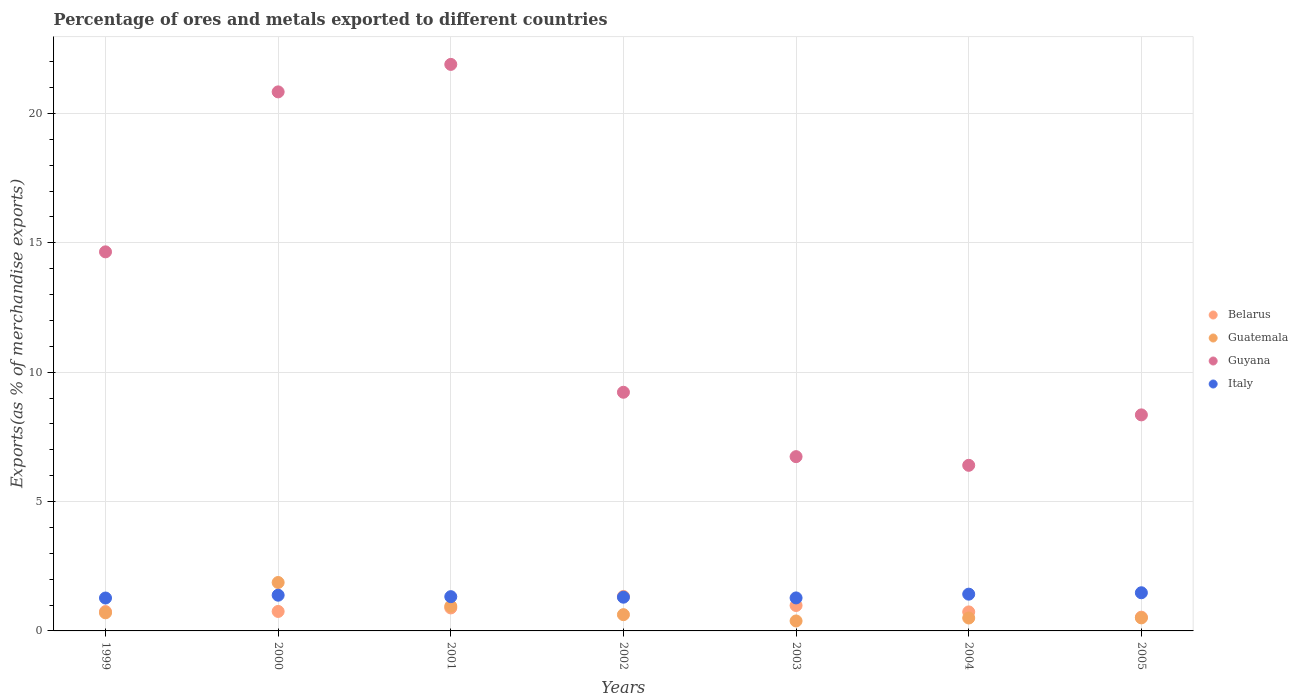How many different coloured dotlines are there?
Provide a short and direct response. 4. Is the number of dotlines equal to the number of legend labels?
Offer a terse response. Yes. What is the percentage of exports to different countries in Guatemala in 2004?
Provide a short and direct response. 0.5. Across all years, what is the maximum percentage of exports to different countries in Italy?
Your answer should be very brief. 1.48. Across all years, what is the minimum percentage of exports to different countries in Guyana?
Offer a very short reply. 6.4. In which year was the percentage of exports to different countries in Guyana maximum?
Your response must be concise. 2001. What is the total percentage of exports to different countries in Guatemala in the graph?
Your response must be concise. 5.54. What is the difference between the percentage of exports to different countries in Italy in 2001 and that in 2002?
Offer a very short reply. 0.02. What is the difference between the percentage of exports to different countries in Guyana in 2004 and the percentage of exports to different countries in Italy in 2003?
Your answer should be compact. 5.13. What is the average percentage of exports to different countries in Guatemala per year?
Make the answer very short. 0.79. In the year 2001, what is the difference between the percentage of exports to different countries in Guatemala and percentage of exports to different countries in Belarus?
Your answer should be very brief. 0.07. What is the ratio of the percentage of exports to different countries in Italy in 1999 to that in 2005?
Keep it short and to the point. 0.86. Is the difference between the percentage of exports to different countries in Guatemala in 2002 and 2005 greater than the difference between the percentage of exports to different countries in Belarus in 2002 and 2005?
Offer a very short reply. No. What is the difference between the highest and the second highest percentage of exports to different countries in Italy?
Make the answer very short. 0.05. What is the difference between the highest and the lowest percentage of exports to different countries in Guyana?
Offer a terse response. 15.5. Is the sum of the percentage of exports to different countries in Italy in 2001 and 2004 greater than the maximum percentage of exports to different countries in Guatemala across all years?
Give a very brief answer. Yes. Is it the case that in every year, the sum of the percentage of exports to different countries in Italy and percentage of exports to different countries in Guatemala  is greater than the percentage of exports to different countries in Guyana?
Your answer should be very brief. No. Does the percentage of exports to different countries in Guatemala monotonically increase over the years?
Ensure brevity in your answer.  No. Is the percentage of exports to different countries in Belarus strictly greater than the percentage of exports to different countries in Guatemala over the years?
Your response must be concise. No. How many dotlines are there?
Keep it short and to the point. 4. Are the values on the major ticks of Y-axis written in scientific E-notation?
Provide a short and direct response. No. Does the graph contain any zero values?
Make the answer very short. No. Does the graph contain grids?
Your answer should be compact. Yes. Where does the legend appear in the graph?
Make the answer very short. Center right. How are the legend labels stacked?
Give a very brief answer. Vertical. What is the title of the graph?
Your answer should be compact. Percentage of ores and metals exported to different countries. Does "Haiti" appear as one of the legend labels in the graph?
Give a very brief answer. No. What is the label or title of the Y-axis?
Provide a short and direct response. Exports(as % of merchandise exports). What is the Exports(as % of merchandise exports) in Belarus in 1999?
Offer a very short reply. 0.75. What is the Exports(as % of merchandise exports) of Guatemala in 1999?
Offer a terse response. 0.7. What is the Exports(as % of merchandise exports) in Guyana in 1999?
Give a very brief answer. 14.65. What is the Exports(as % of merchandise exports) of Italy in 1999?
Your answer should be very brief. 1.27. What is the Exports(as % of merchandise exports) of Belarus in 2000?
Make the answer very short. 0.75. What is the Exports(as % of merchandise exports) of Guatemala in 2000?
Your answer should be compact. 1.87. What is the Exports(as % of merchandise exports) of Guyana in 2000?
Provide a succinct answer. 20.83. What is the Exports(as % of merchandise exports) in Italy in 2000?
Offer a terse response. 1.38. What is the Exports(as % of merchandise exports) in Belarus in 2001?
Provide a short and direct response. 0.89. What is the Exports(as % of merchandise exports) in Guatemala in 2001?
Your answer should be compact. 0.96. What is the Exports(as % of merchandise exports) of Guyana in 2001?
Your answer should be very brief. 21.9. What is the Exports(as % of merchandise exports) in Italy in 2001?
Provide a short and direct response. 1.32. What is the Exports(as % of merchandise exports) in Belarus in 2002?
Ensure brevity in your answer.  1.33. What is the Exports(as % of merchandise exports) of Guatemala in 2002?
Give a very brief answer. 0.63. What is the Exports(as % of merchandise exports) of Guyana in 2002?
Your response must be concise. 9.22. What is the Exports(as % of merchandise exports) of Italy in 2002?
Provide a succinct answer. 1.3. What is the Exports(as % of merchandise exports) in Belarus in 2003?
Provide a short and direct response. 0.98. What is the Exports(as % of merchandise exports) in Guatemala in 2003?
Ensure brevity in your answer.  0.39. What is the Exports(as % of merchandise exports) of Guyana in 2003?
Your response must be concise. 6.74. What is the Exports(as % of merchandise exports) of Italy in 2003?
Make the answer very short. 1.28. What is the Exports(as % of merchandise exports) of Belarus in 2004?
Make the answer very short. 0.73. What is the Exports(as % of merchandise exports) in Guatemala in 2004?
Provide a succinct answer. 0.5. What is the Exports(as % of merchandise exports) in Guyana in 2004?
Provide a short and direct response. 6.4. What is the Exports(as % of merchandise exports) in Italy in 2004?
Offer a terse response. 1.42. What is the Exports(as % of merchandise exports) of Belarus in 2005?
Provide a short and direct response. 0.53. What is the Exports(as % of merchandise exports) in Guatemala in 2005?
Offer a terse response. 0.5. What is the Exports(as % of merchandise exports) in Guyana in 2005?
Offer a terse response. 8.35. What is the Exports(as % of merchandise exports) in Italy in 2005?
Offer a very short reply. 1.48. Across all years, what is the maximum Exports(as % of merchandise exports) of Belarus?
Offer a very short reply. 1.33. Across all years, what is the maximum Exports(as % of merchandise exports) in Guatemala?
Your answer should be very brief. 1.87. Across all years, what is the maximum Exports(as % of merchandise exports) of Guyana?
Offer a terse response. 21.9. Across all years, what is the maximum Exports(as % of merchandise exports) of Italy?
Keep it short and to the point. 1.48. Across all years, what is the minimum Exports(as % of merchandise exports) in Belarus?
Ensure brevity in your answer.  0.53. Across all years, what is the minimum Exports(as % of merchandise exports) in Guatemala?
Provide a succinct answer. 0.39. Across all years, what is the minimum Exports(as % of merchandise exports) in Guyana?
Ensure brevity in your answer.  6.4. Across all years, what is the minimum Exports(as % of merchandise exports) in Italy?
Give a very brief answer. 1.27. What is the total Exports(as % of merchandise exports) in Belarus in the graph?
Your response must be concise. 5.97. What is the total Exports(as % of merchandise exports) of Guatemala in the graph?
Provide a succinct answer. 5.54. What is the total Exports(as % of merchandise exports) in Guyana in the graph?
Provide a succinct answer. 88.09. What is the total Exports(as % of merchandise exports) of Italy in the graph?
Offer a very short reply. 9.45. What is the difference between the Exports(as % of merchandise exports) of Belarus in 1999 and that in 2000?
Provide a short and direct response. -0. What is the difference between the Exports(as % of merchandise exports) in Guatemala in 1999 and that in 2000?
Keep it short and to the point. -1.17. What is the difference between the Exports(as % of merchandise exports) of Guyana in 1999 and that in 2000?
Offer a very short reply. -6.18. What is the difference between the Exports(as % of merchandise exports) in Italy in 1999 and that in 2000?
Ensure brevity in your answer.  -0.11. What is the difference between the Exports(as % of merchandise exports) in Belarus in 1999 and that in 2001?
Your answer should be very brief. -0.14. What is the difference between the Exports(as % of merchandise exports) in Guatemala in 1999 and that in 2001?
Make the answer very short. -0.26. What is the difference between the Exports(as % of merchandise exports) of Guyana in 1999 and that in 2001?
Give a very brief answer. -7.25. What is the difference between the Exports(as % of merchandise exports) in Italy in 1999 and that in 2001?
Make the answer very short. -0.05. What is the difference between the Exports(as % of merchandise exports) in Belarus in 1999 and that in 2002?
Give a very brief answer. -0.58. What is the difference between the Exports(as % of merchandise exports) in Guatemala in 1999 and that in 2002?
Your response must be concise. 0.07. What is the difference between the Exports(as % of merchandise exports) in Guyana in 1999 and that in 2002?
Offer a very short reply. 5.43. What is the difference between the Exports(as % of merchandise exports) in Italy in 1999 and that in 2002?
Give a very brief answer. -0.03. What is the difference between the Exports(as % of merchandise exports) in Belarus in 1999 and that in 2003?
Offer a terse response. -0.23. What is the difference between the Exports(as % of merchandise exports) in Guatemala in 1999 and that in 2003?
Give a very brief answer. 0.31. What is the difference between the Exports(as % of merchandise exports) of Guyana in 1999 and that in 2003?
Give a very brief answer. 7.92. What is the difference between the Exports(as % of merchandise exports) of Italy in 1999 and that in 2003?
Your response must be concise. -0. What is the difference between the Exports(as % of merchandise exports) of Belarus in 1999 and that in 2004?
Provide a succinct answer. 0.01. What is the difference between the Exports(as % of merchandise exports) of Guatemala in 1999 and that in 2004?
Offer a very short reply. 0.2. What is the difference between the Exports(as % of merchandise exports) in Guyana in 1999 and that in 2004?
Your answer should be compact. 8.25. What is the difference between the Exports(as % of merchandise exports) in Italy in 1999 and that in 2004?
Offer a very short reply. -0.15. What is the difference between the Exports(as % of merchandise exports) of Belarus in 1999 and that in 2005?
Give a very brief answer. 0.22. What is the difference between the Exports(as % of merchandise exports) of Guatemala in 1999 and that in 2005?
Ensure brevity in your answer.  0.2. What is the difference between the Exports(as % of merchandise exports) of Guyana in 1999 and that in 2005?
Your answer should be compact. 6.3. What is the difference between the Exports(as % of merchandise exports) in Italy in 1999 and that in 2005?
Your response must be concise. -0.2. What is the difference between the Exports(as % of merchandise exports) of Belarus in 2000 and that in 2001?
Your answer should be very brief. -0.14. What is the difference between the Exports(as % of merchandise exports) of Guatemala in 2000 and that in 2001?
Make the answer very short. 0.92. What is the difference between the Exports(as % of merchandise exports) of Guyana in 2000 and that in 2001?
Give a very brief answer. -1.06. What is the difference between the Exports(as % of merchandise exports) of Italy in 2000 and that in 2001?
Your answer should be very brief. 0.06. What is the difference between the Exports(as % of merchandise exports) of Belarus in 2000 and that in 2002?
Keep it short and to the point. -0.58. What is the difference between the Exports(as % of merchandise exports) in Guatemala in 2000 and that in 2002?
Provide a succinct answer. 1.24. What is the difference between the Exports(as % of merchandise exports) in Guyana in 2000 and that in 2002?
Offer a very short reply. 11.61. What is the difference between the Exports(as % of merchandise exports) in Italy in 2000 and that in 2002?
Provide a short and direct response. 0.08. What is the difference between the Exports(as % of merchandise exports) in Belarus in 2000 and that in 2003?
Give a very brief answer. -0.23. What is the difference between the Exports(as % of merchandise exports) in Guatemala in 2000 and that in 2003?
Offer a terse response. 1.49. What is the difference between the Exports(as % of merchandise exports) in Guyana in 2000 and that in 2003?
Your answer should be compact. 14.1. What is the difference between the Exports(as % of merchandise exports) of Italy in 2000 and that in 2003?
Provide a succinct answer. 0.1. What is the difference between the Exports(as % of merchandise exports) in Belarus in 2000 and that in 2004?
Ensure brevity in your answer.  0.02. What is the difference between the Exports(as % of merchandise exports) of Guatemala in 2000 and that in 2004?
Make the answer very short. 1.37. What is the difference between the Exports(as % of merchandise exports) in Guyana in 2000 and that in 2004?
Offer a very short reply. 14.43. What is the difference between the Exports(as % of merchandise exports) in Italy in 2000 and that in 2004?
Your response must be concise. -0.04. What is the difference between the Exports(as % of merchandise exports) of Belarus in 2000 and that in 2005?
Keep it short and to the point. 0.22. What is the difference between the Exports(as % of merchandise exports) in Guatemala in 2000 and that in 2005?
Offer a very short reply. 1.37. What is the difference between the Exports(as % of merchandise exports) of Guyana in 2000 and that in 2005?
Give a very brief answer. 12.48. What is the difference between the Exports(as % of merchandise exports) of Italy in 2000 and that in 2005?
Your answer should be very brief. -0.09. What is the difference between the Exports(as % of merchandise exports) in Belarus in 2001 and that in 2002?
Provide a succinct answer. -0.44. What is the difference between the Exports(as % of merchandise exports) of Guatemala in 2001 and that in 2002?
Ensure brevity in your answer.  0.33. What is the difference between the Exports(as % of merchandise exports) in Guyana in 2001 and that in 2002?
Make the answer very short. 12.67. What is the difference between the Exports(as % of merchandise exports) in Italy in 2001 and that in 2002?
Provide a succinct answer. 0.02. What is the difference between the Exports(as % of merchandise exports) of Belarus in 2001 and that in 2003?
Keep it short and to the point. -0.09. What is the difference between the Exports(as % of merchandise exports) of Guatemala in 2001 and that in 2003?
Ensure brevity in your answer.  0.57. What is the difference between the Exports(as % of merchandise exports) in Guyana in 2001 and that in 2003?
Your answer should be very brief. 15.16. What is the difference between the Exports(as % of merchandise exports) in Italy in 2001 and that in 2003?
Provide a short and direct response. 0.05. What is the difference between the Exports(as % of merchandise exports) in Belarus in 2001 and that in 2004?
Ensure brevity in your answer.  0.15. What is the difference between the Exports(as % of merchandise exports) of Guatemala in 2001 and that in 2004?
Give a very brief answer. 0.46. What is the difference between the Exports(as % of merchandise exports) of Guyana in 2001 and that in 2004?
Your response must be concise. 15.5. What is the difference between the Exports(as % of merchandise exports) in Italy in 2001 and that in 2004?
Offer a terse response. -0.1. What is the difference between the Exports(as % of merchandise exports) in Belarus in 2001 and that in 2005?
Ensure brevity in your answer.  0.36. What is the difference between the Exports(as % of merchandise exports) in Guatemala in 2001 and that in 2005?
Provide a succinct answer. 0.45. What is the difference between the Exports(as % of merchandise exports) in Guyana in 2001 and that in 2005?
Give a very brief answer. 13.55. What is the difference between the Exports(as % of merchandise exports) of Italy in 2001 and that in 2005?
Your response must be concise. -0.15. What is the difference between the Exports(as % of merchandise exports) of Belarus in 2002 and that in 2003?
Provide a succinct answer. 0.35. What is the difference between the Exports(as % of merchandise exports) in Guatemala in 2002 and that in 2003?
Provide a short and direct response. 0.24. What is the difference between the Exports(as % of merchandise exports) of Guyana in 2002 and that in 2003?
Make the answer very short. 2.49. What is the difference between the Exports(as % of merchandise exports) in Italy in 2002 and that in 2003?
Keep it short and to the point. 0.03. What is the difference between the Exports(as % of merchandise exports) in Belarus in 2002 and that in 2004?
Your response must be concise. 0.6. What is the difference between the Exports(as % of merchandise exports) in Guatemala in 2002 and that in 2004?
Provide a succinct answer. 0.13. What is the difference between the Exports(as % of merchandise exports) of Guyana in 2002 and that in 2004?
Provide a short and direct response. 2.82. What is the difference between the Exports(as % of merchandise exports) of Italy in 2002 and that in 2004?
Ensure brevity in your answer.  -0.12. What is the difference between the Exports(as % of merchandise exports) of Belarus in 2002 and that in 2005?
Give a very brief answer. 0.8. What is the difference between the Exports(as % of merchandise exports) in Guatemala in 2002 and that in 2005?
Keep it short and to the point. 0.12. What is the difference between the Exports(as % of merchandise exports) of Guyana in 2002 and that in 2005?
Provide a short and direct response. 0.87. What is the difference between the Exports(as % of merchandise exports) of Italy in 2002 and that in 2005?
Your answer should be compact. -0.17. What is the difference between the Exports(as % of merchandise exports) of Belarus in 2003 and that in 2004?
Your answer should be compact. 0.25. What is the difference between the Exports(as % of merchandise exports) in Guatemala in 2003 and that in 2004?
Provide a succinct answer. -0.11. What is the difference between the Exports(as % of merchandise exports) in Guyana in 2003 and that in 2004?
Your answer should be compact. 0.34. What is the difference between the Exports(as % of merchandise exports) of Italy in 2003 and that in 2004?
Offer a terse response. -0.15. What is the difference between the Exports(as % of merchandise exports) of Belarus in 2003 and that in 2005?
Ensure brevity in your answer.  0.45. What is the difference between the Exports(as % of merchandise exports) in Guatemala in 2003 and that in 2005?
Provide a succinct answer. -0.12. What is the difference between the Exports(as % of merchandise exports) in Guyana in 2003 and that in 2005?
Your answer should be compact. -1.61. What is the difference between the Exports(as % of merchandise exports) in Italy in 2003 and that in 2005?
Your answer should be very brief. -0.2. What is the difference between the Exports(as % of merchandise exports) in Belarus in 2004 and that in 2005?
Provide a succinct answer. 0.2. What is the difference between the Exports(as % of merchandise exports) in Guatemala in 2004 and that in 2005?
Your answer should be compact. -0. What is the difference between the Exports(as % of merchandise exports) in Guyana in 2004 and that in 2005?
Offer a very short reply. -1.95. What is the difference between the Exports(as % of merchandise exports) of Italy in 2004 and that in 2005?
Offer a very short reply. -0.05. What is the difference between the Exports(as % of merchandise exports) in Belarus in 1999 and the Exports(as % of merchandise exports) in Guatemala in 2000?
Keep it short and to the point. -1.12. What is the difference between the Exports(as % of merchandise exports) in Belarus in 1999 and the Exports(as % of merchandise exports) in Guyana in 2000?
Provide a short and direct response. -20.09. What is the difference between the Exports(as % of merchandise exports) in Belarus in 1999 and the Exports(as % of merchandise exports) in Italy in 2000?
Your answer should be very brief. -0.63. What is the difference between the Exports(as % of merchandise exports) of Guatemala in 1999 and the Exports(as % of merchandise exports) of Guyana in 2000?
Your answer should be compact. -20.13. What is the difference between the Exports(as % of merchandise exports) of Guatemala in 1999 and the Exports(as % of merchandise exports) of Italy in 2000?
Ensure brevity in your answer.  -0.68. What is the difference between the Exports(as % of merchandise exports) of Guyana in 1999 and the Exports(as % of merchandise exports) of Italy in 2000?
Offer a very short reply. 13.27. What is the difference between the Exports(as % of merchandise exports) in Belarus in 1999 and the Exports(as % of merchandise exports) in Guatemala in 2001?
Your answer should be very brief. -0.21. What is the difference between the Exports(as % of merchandise exports) in Belarus in 1999 and the Exports(as % of merchandise exports) in Guyana in 2001?
Give a very brief answer. -21.15. What is the difference between the Exports(as % of merchandise exports) of Belarus in 1999 and the Exports(as % of merchandise exports) of Italy in 2001?
Your answer should be very brief. -0.58. What is the difference between the Exports(as % of merchandise exports) of Guatemala in 1999 and the Exports(as % of merchandise exports) of Guyana in 2001?
Make the answer very short. -21.2. What is the difference between the Exports(as % of merchandise exports) in Guatemala in 1999 and the Exports(as % of merchandise exports) in Italy in 2001?
Make the answer very short. -0.62. What is the difference between the Exports(as % of merchandise exports) in Guyana in 1999 and the Exports(as % of merchandise exports) in Italy in 2001?
Your answer should be very brief. 13.33. What is the difference between the Exports(as % of merchandise exports) of Belarus in 1999 and the Exports(as % of merchandise exports) of Guatemala in 2002?
Keep it short and to the point. 0.12. What is the difference between the Exports(as % of merchandise exports) in Belarus in 1999 and the Exports(as % of merchandise exports) in Guyana in 2002?
Provide a succinct answer. -8.48. What is the difference between the Exports(as % of merchandise exports) in Belarus in 1999 and the Exports(as % of merchandise exports) in Italy in 2002?
Keep it short and to the point. -0.56. What is the difference between the Exports(as % of merchandise exports) of Guatemala in 1999 and the Exports(as % of merchandise exports) of Guyana in 2002?
Your response must be concise. -8.52. What is the difference between the Exports(as % of merchandise exports) of Guatemala in 1999 and the Exports(as % of merchandise exports) of Italy in 2002?
Provide a short and direct response. -0.6. What is the difference between the Exports(as % of merchandise exports) in Guyana in 1999 and the Exports(as % of merchandise exports) in Italy in 2002?
Provide a short and direct response. 13.35. What is the difference between the Exports(as % of merchandise exports) of Belarus in 1999 and the Exports(as % of merchandise exports) of Guatemala in 2003?
Ensure brevity in your answer.  0.36. What is the difference between the Exports(as % of merchandise exports) in Belarus in 1999 and the Exports(as % of merchandise exports) in Guyana in 2003?
Your answer should be very brief. -5.99. What is the difference between the Exports(as % of merchandise exports) of Belarus in 1999 and the Exports(as % of merchandise exports) of Italy in 2003?
Provide a short and direct response. -0.53. What is the difference between the Exports(as % of merchandise exports) in Guatemala in 1999 and the Exports(as % of merchandise exports) in Guyana in 2003?
Ensure brevity in your answer.  -6.04. What is the difference between the Exports(as % of merchandise exports) of Guatemala in 1999 and the Exports(as % of merchandise exports) of Italy in 2003?
Give a very brief answer. -0.58. What is the difference between the Exports(as % of merchandise exports) of Guyana in 1999 and the Exports(as % of merchandise exports) of Italy in 2003?
Offer a very short reply. 13.38. What is the difference between the Exports(as % of merchandise exports) of Belarus in 1999 and the Exports(as % of merchandise exports) of Guatemala in 2004?
Offer a very short reply. 0.25. What is the difference between the Exports(as % of merchandise exports) of Belarus in 1999 and the Exports(as % of merchandise exports) of Guyana in 2004?
Your answer should be very brief. -5.65. What is the difference between the Exports(as % of merchandise exports) in Belarus in 1999 and the Exports(as % of merchandise exports) in Italy in 2004?
Provide a succinct answer. -0.67. What is the difference between the Exports(as % of merchandise exports) of Guatemala in 1999 and the Exports(as % of merchandise exports) of Guyana in 2004?
Offer a very short reply. -5.7. What is the difference between the Exports(as % of merchandise exports) in Guatemala in 1999 and the Exports(as % of merchandise exports) in Italy in 2004?
Provide a short and direct response. -0.72. What is the difference between the Exports(as % of merchandise exports) of Guyana in 1999 and the Exports(as % of merchandise exports) of Italy in 2004?
Provide a succinct answer. 13.23. What is the difference between the Exports(as % of merchandise exports) in Belarus in 1999 and the Exports(as % of merchandise exports) in Guatemala in 2005?
Make the answer very short. 0.24. What is the difference between the Exports(as % of merchandise exports) in Belarus in 1999 and the Exports(as % of merchandise exports) in Guyana in 2005?
Provide a succinct answer. -7.6. What is the difference between the Exports(as % of merchandise exports) of Belarus in 1999 and the Exports(as % of merchandise exports) of Italy in 2005?
Offer a terse response. -0.73. What is the difference between the Exports(as % of merchandise exports) in Guatemala in 1999 and the Exports(as % of merchandise exports) in Guyana in 2005?
Keep it short and to the point. -7.65. What is the difference between the Exports(as % of merchandise exports) in Guatemala in 1999 and the Exports(as % of merchandise exports) in Italy in 2005?
Provide a short and direct response. -0.78. What is the difference between the Exports(as % of merchandise exports) of Guyana in 1999 and the Exports(as % of merchandise exports) of Italy in 2005?
Your answer should be compact. 13.18. What is the difference between the Exports(as % of merchandise exports) of Belarus in 2000 and the Exports(as % of merchandise exports) of Guatemala in 2001?
Provide a succinct answer. -0.2. What is the difference between the Exports(as % of merchandise exports) of Belarus in 2000 and the Exports(as % of merchandise exports) of Guyana in 2001?
Ensure brevity in your answer.  -21.14. What is the difference between the Exports(as % of merchandise exports) in Belarus in 2000 and the Exports(as % of merchandise exports) in Italy in 2001?
Your answer should be very brief. -0.57. What is the difference between the Exports(as % of merchandise exports) of Guatemala in 2000 and the Exports(as % of merchandise exports) of Guyana in 2001?
Keep it short and to the point. -20.02. What is the difference between the Exports(as % of merchandise exports) of Guatemala in 2000 and the Exports(as % of merchandise exports) of Italy in 2001?
Your response must be concise. 0.55. What is the difference between the Exports(as % of merchandise exports) of Guyana in 2000 and the Exports(as % of merchandise exports) of Italy in 2001?
Your answer should be compact. 19.51. What is the difference between the Exports(as % of merchandise exports) in Belarus in 2000 and the Exports(as % of merchandise exports) in Guatemala in 2002?
Keep it short and to the point. 0.12. What is the difference between the Exports(as % of merchandise exports) of Belarus in 2000 and the Exports(as % of merchandise exports) of Guyana in 2002?
Offer a very short reply. -8.47. What is the difference between the Exports(as % of merchandise exports) of Belarus in 2000 and the Exports(as % of merchandise exports) of Italy in 2002?
Offer a very short reply. -0.55. What is the difference between the Exports(as % of merchandise exports) of Guatemala in 2000 and the Exports(as % of merchandise exports) of Guyana in 2002?
Provide a succinct answer. -7.35. What is the difference between the Exports(as % of merchandise exports) of Guatemala in 2000 and the Exports(as % of merchandise exports) of Italy in 2002?
Offer a very short reply. 0.57. What is the difference between the Exports(as % of merchandise exports) in Guyana in 2000 and the Exports(as % of merchandise exports) in Italy in 2002?
Offer a terse response. 19.53. What is the difference between the Exports(as % of merchandise exports) of Belarus in 2000 and the Exports(as % of merchandise exports) of Guatemala in 2003?
Offer a terse response. 0.37. What is the difference between the Exports(as % of merchandise exports) of Belarus in 2000 and the Exports(as % of merchandise exports) of Guyana in 2003?
Keep it short and to the point. -5.98. What is the difference between the Exports(as % of merchandise exports) in Belarus in 2000 and the Exports(as % of merchandise exports) in Italy in 2003?
Keep it short and to the point. -0.52. What is the difference between the Exports(as % of merchandise exports) of Guatemala in 2000 and the Exports(as % of merchandise exports) of Guyana in 2003?
Keep it short and to the point. -4.86. What is the difference between the Exports(as % of merchandise exports) of Guatemala in 2000 and the Exports(as % of merchandise exports) of Italy in 2003?
Provide a short and direct response. 0.6. What is the difference between the Exports(as % of merchandise exports) in Guyana in 2000 and the Exports(as % of merchandise exports) in Italy in 2003?
Keep it short and to the point. 19.56. What is the difference between the Exports(as % of merchandise exports) of Belarus in 2000 and the Exports(as % of merchandise exports) of Guatemala in 2004?
Ensure brevity in your answer.  0.25. What is the difference between the Exports(as % of merchandise exports) of Belarus in 2000 and the Exports(as % of merchandise exports) of Guyana in 2004?
Make the answer very short. -5.65. What is the difference between the Exports(as % of merchandise exports) of Belarus in 2000 and the Exports(as % of merchandise exports) of Italy in 2004?
Ensure brevity in your answer.  -0.67. What is the difference between the Exports(as % of merchandise exports) of Guatemala in 2000 and the Exports(as % of merchandise exports) of Guyana in 2004?
Offer a very short reply. -4.53. What is the difference between the Exports(as % of merchandise exports) in Guatemala in 2000 and the Exports(as % of merchandise exports) in Italy in 2004?
Provide a succinct answer. 0.45. What is the difference between the Exports(as % of merchandise exports) of Guyana in 2000 and the Exports(as % of merchandise exports) of Italy in 2004?
Your answer should be very brief. 19.41. What is the difference between the Exports(as % of merchandise exports) in Belarus in 2000 and the Exports(as % of merchandise exports) in Guatemala in 2005?
Keep it short and to the point. 0.25. What is the difference between the Exports(as % of merchandise exports) in Belarus in 2000 and the Exports(as % of merchandise exports) in Guyana in 2005?
Provide a succinct answer. -7.6. What is the difference between the Exports(as % of merchandise exports) of Belarus in 2000 and the Exports(as % of merchandise exports) of Italy in 2005?
Give a very brief answer. -0.72. What is the difference between the Exports(as % of merchandise exports) in Guatemala in 2000 and the Exports(as % of merchandise exports) in Guyana in 2005?
Offer a very short reply. -6.48. What is the difference between the Exports(as % of merchandise exports) of Guatemala in 2000 and the Exports(as % of merchandise exports) of Italy in 2005?
Offer a very short reply. 0.4. What is the difference between the Exports(as % of merchandise exports) of Guyana in 2000 and the Exports(as % of merchandise exports) of Italy in 2005?
Give a very brief answer. 19.36. What is the difference between the Exports(as % of merchandise exports) of Belarus in 2001 and the Exports(as % of merchandise exports) of Guatemala in 2002?
Provide a succinct answer. 0.26. What is the difference between the Exports(as % of merchandise exports) of Belarus in 2001 and the Exports(as % of merchandise exports) of Guyana in 2002?
Your response must be concise. -8.34. What is the difference between the Exports(as % of merchandise exports) of Belarus in 2001 and the Exports(as % of merchandise exports) of Italy in 2002?
Make the answer very short. -0.42. What is the difference between the Exports(as % of merchandise exports) in Guatemala in 2001 and the Exports(as % of merchandise exports) in Guyana in 2002?
Provide a short and direct response. -8.27. What is the difference between the Exports(as % of merchandise exports) in Guatemala in 2001 and the Exports(as % of merchandise exports) in Italy in 2002?
Provide a succinct answer. -0.35. What is the difference between the Exports(as % of merchandise exports) in Guyana in 2001 and the Exports(as % of merchandise exports) in Italy in 2002?
Offer a very short reply. 20.59. What is the difference between the Exports(as % of merchandise exports) in Belarus in 2001 and the Exports(as % of merchandise exports) in Guatemala in 2003?
Make the answer very short. 0.5. What is the difference between the Exports(as % of merchandise exports) of Belarus in 2001 and the Exports(as % of merchandise exports) of Guyana in 2003?
Provide a short and direct response. -5.85. What is the difference between the Exports(as % of merchandise exports) in Belarus in 2001 and the Exports(as % of merchandise exports) in Italy in 2003?
Provide a short and direct response. -0.39. What is the difference between the Exports(as % of merchandise exports) of Guatemala in 2001 and the Exports(as % of merchandise exports) of Guyana in 2003?
Offer a very short reply. -5.78. What is the difference between the Exports(as % of merchandise exports) of Guatemala in 2001 and the Exports(as % of merchandise exports) of Italy in 2003?
Provide a succinct answer. -0.32. What is the difference between the Exports(as % of merchandise exports) of Guyana in 2001 and the Exports(as % of merchandise exports) of Italy in 2003?
Provide a succinct answer. 20.62. What is the difference between the Exports(as % of merchandise exports) of Belarus in 2001 and the Exports(as % of merchandise exports) of Guatemala in 2004?
Offer a terse response. 0.39. What is the difference between the Exports(as % of merchandise exports) in Belarus in 2001 and the Exports(as % of merchandise exports) in Guyana in 2004?
Ensure brevity in your answer.  -5.51. What is the difference between the Exports(as % of merchandise exports) of Belarus in 2001 and the Exports(as % of merchandise exports) of Italy in 2004?
Keep it short and to the point. -0.53. What is the difference between the Exports(as % of merchandise exports) in Guatemala in 2001 and the Exports(as % of merchandise exports) in Guyana in 2004?
Keep it short and to the point. -5.44. What is the difference between the Exports(as % of merchandise exports) in Guatemala in 2001 and the Exports(as % of merchandise exports) in Italy in 2004?
Provide a short and direct response. -0.46. What is the difference between the Exports(as % of merchandise exports) of Guyana in 2001 and the Exports(as % of merchandise exports) of Italy in 2004?
Your response must be concise. 20.48. What is the difference between the Exports(as % of merchandise exports) of Belarus in 2001 and the Exports(as % of merchandise exports) of Guatemala in 2005?
Make the answer very short. 0.38. What is the difference between the Exports(as % of merchandise exports) in Belarus in 2001 and the Exports(as % of merchandise exports) in Guyana in 2005?
Provide a short and direct response. -7.46. What is the difference between the Exports(as % of merchandise exports) of Belarus in 2001 and the Exports(as % of merchandise exports) of Italy in 2005?
Your answer should be very brief. -0.59. What is the difference between the Exports(as % of merchandise exports) of Guatemala in 2001 and the Exports(as % of merchandise exports) of Guyana in 2005?
Your answer should be compact. -7.39. What is the difference between the Exports(as % of merchandise exports) in Guatemala in 2001 and the Exports(as % of merchandise exports) in Italy in 2005?
Your answer should be very brief. -0.52. What is the difference between the Exports(as % of merchandise exports) of Guyana in 2001 and the Exports(as % of merchandise exports) of Italy in 2005?
Provide a succinct answer. 20.42. What is the difference between the Exports(as % of merchandise exports) of Belarus in 2002 and the Exports(as % of merchandise exports) of Guatemala in 2003?
Ensure brevity in your answer.  0.95. What is the difference between the Exports(as % of merchandise exports) of Belarus in 2002 and the Exports(as % of merchandise exports) of Guyana in 2003?
Make the answer very short. -5.4. What is the difference between the Exports(as % of merchandise exports) in Belarus in 2002 and the Exports(as % of merchandise exports) in Italy in 2003?
Make the answer very short. 0.06. What is the difference between the Exports(as % of merchandise exports) of Guatemala in 2002 and the Exports(as % of merchandise exports) of Guyana in 2003?
Your answer should be very brief. -6.11. What is the difference between the Exports(as % of merchandise exports) of Guatemala in 2002 and the Exports(as % of merchandise exports) of Italy in 2003?
Offer a terse response. -0.65. What is the difference between the Exports(as % of merchandise exports) of Guyana in 2002 and the Exports(as % of merchandise exports) of Italy in 2003?
Offer a very short reply. 7.95. What is the difference between the Exports(as % of merchandise exports) of Belarus in 2002 and the Exports(as % of merchandise exports) of Guatemala in 2004?
Provide a succinct answer. 0.83. What is the difference between the Exports(as % of merchandise exports) in Belarus in 2002 and the Exports(as % of merchandise exports) in Guyana in 2004?
Make the answer very short. -5.07. What is the difference between the Exports(as % of merchandise exports) in Belarus in 2002 and the Exports(as % of merchandise exports) in Italy in 2004?
Give a very brief answer. -0.09. What is the difference between the Exports(as % of merchandise exports) of Guatemala in 2002 and the Exports(as % of merchandise exports) of Guyana in 2004?
Your answer should be very brief. -5.77. What is the difference between the Exports(as % of merchandise exports) in Guatemala in 2002 and the Exports(as % of merchandise exports) in Italy in 2004?
Offer a very short reply. -0.79. What is the difference between the Exports(as % of merchandise exports) in Guyana in 2002 and the Exports(as % of merchandise exports) in Italy in 2004?
Offer a terse response. 7.8. What is the difference between the Exports(as % of merchandise exports) in Belarus in 2002 and the Exports(as % of merchandise exports) in Guatemala in 2005?
Offer a terse response. 0.83. What is the difference between the Exports(as % of merchandise exports) in Belarus in 2002 and the Exports(as % of merchandise exports) in Guyana in 2005?
Your answer should be compact. -7.02. What is the difference between the Exports(as % of merchandise exports) of Belarus in 2002 and the Exports(as % of merchandise exports) of Italy in 2005?
Offer a terse response. -0.14. What is the difference between the Exports(as % of merchandise exports) in Guatemala in 2002 and the Exports(as % of merchandise exports) in Guyana in 2005?
Offer a very short reply. -7.72. What is the difference between the Exports(as % of merchandise exports) in Guatemala in 2002 and the Exports(as % of merchandise exports) in Italy in 2005?
Offer a very short reply. -0.85. What is the difference between the Exports(as % of merchandise exports) in Guyana in 2002 and the Exports(as % of merchandise exports) in Italy in 2005?
Keep it short and to the point. 7.75. What is the difference between the Exports(as % of merchandise exports) of Belarus in 2003 and the Exports(as % of merchandise exports) of Guatemala in 2004?
Your response must be concise. 0.48. What is the difference between the Exports(as % of merchandise exports) of Belarus in 2003 and the Exports(as % of merchandise exports) of Guyana in 2004?
Offer a very short reply. -5.42. What is the difference between the Exports(as % of merchandise exports) in Belarus in 2003 and the Exports(as % of merchandise exports) in Italy in 2004?
Offer a very short reply. -0.44. What is the difference between the Exports(as % of merchandise exports) of Guatemala in 2003 and the Exports(as % of merchandise exports) of Guyana in 2004?
Give a very brief answer. -6.02. What is the difference between the Exports(as % of merchandise exports) in Guatemala in 2003 and the Exports(as % of merchandise exports) in Italy in 2004?
Keep it short and to the point. -1.04. What is the difference between the Exports(as % of merchandise exports) of Guyana in 2003 and the Exports(as % of merchandise exports) of Italy in 2004?
Make the answer very short. 5.32. What is the difference between the Exports(as % of merchandise exports) of Belarus in 2003 and the Exports(as % of merchandise exports) of Guatemala in 2005?
Make the answer very short. 0.48. What is the difference between the Exports(as % of merchandise exports) of Belarus in 2003 and the Exports(as % of merchandise exports) of Guyana in 2005?
Keep it short and to the point. -7.37. What is the difference between the Exports(as % of merchandise exports) of Belarus in 2003 and the Exports(as % of merchandise exports) of Italy in 2005?
Give a very brief answer. -0.49. What is the difference between the Exports(as % of merchandise exports) in Guatemala in 2003 and the Exports(as % of merchandise exports) in Guyana in 2005?
Keep it short and to the point. -7.96. What is the difference between the Exports(as % of merchandise exports) of Guatemala in 2003 and the Exports(as % of merchandise exports) of Italy in 2005?
Offer a terse response. -1.09. What is the difference between the Exports(as % of merchandise exports) in Guyana in 2003 and the Exports(as % of merchandise exports) in Italy in 2005?
Your response must be concise. 5.26. What is the difference between the Exports(as % of merchandise exports) of Belarus in 2004 and the Exports(as % of merchandise exports) of Guatemala in 2005?
Offer a terse response. 0.23. What is the difference between the Exports(as % of merchandise exports) in Belarus in 2004 and the Exports(as % of merchandise exports) in Guyana in 2005?
Provide a short and direct response. -7.62. What is the difference between the Exports(as % of merchandise exports) in Belarus in 2004 and the Exports(as % of merchandise exports) in Italy in 2005?
Offer a terse response. -0.74. What is the difference between the Exports(as % of merchandise exports) of Guatemala in 2004 and the Exports(as % of merchandise exports) of Guyana in 2005?
Provide a short and direct response. -7.85. What is the difference between the Exports(as % of merchandise exports) of Guatemala in 2004 and the Exports(as % of merchandise exports) of Italy in 2005?
Provide a short and direct response. -0.98. What is the difference between the Exports(as % of merchandise exports) of Guyana in 2004 and the Exports(as % of merchandise exports) of Italy in 2005?
Ensure brevity in your answer.  4.93. What is the average Exports(as % of merchandise exports) in Belarus per year?
Offer a terse response. 0.85. What is the average Exports(as % of merchandise exports) of Guatemala per year?
Keep it short and to the point. 0.79. What is the average Exports(as % of merchandise exports) of Guyana per year?
Provide a succinct answer. 12.58. What is the average Exports(as % of merchandise exports) in Italy per year?
Make the answer very short. 1.35. In the year 1999, what is the difference between the Exports(as % of merchandise exports) of Belarus and Exports(as % of merchandise exports) of Guatemala?
Offer a terse response. 0.05. In the year 1999, what is the difference between the Exports(as % of merchandise exports) of Belarus and Exports(as % of merchandise exports) of Guyana?
Make the answer very short. -13.9. In the year 1999, what is the difference between the Exports(as % of merchandise exports) of Belarus and Exports(as % of merchandise exports) of Italy?
Ensure brevity in your answer.  -0.52. In the year 1999, what is the difference between the Exports(as % of merchandise exports) of Guatemala and Exports(as % of merchandise exports) of Guyana?
Offer a very short reply. -13.95. In the year 1999, what is the difference between the Exports(as % of merchandise exports) of Guatemala and Exports(as % of merchandise exports) of Italy?
Offer a very short reply. -0.57. In the year 1999, what is the difference between the Exports(as % of merchandise exports) in Guyana and Exports(as % of merchandise exports) in Italy?
Give a very brief answer. 13.38. In the year 2000, what is the difference between the Exports(as % of merchandise exports) of Belarus and Exports(as % of merchandise exports) of Guatemala?
Keep it short and to the point. -1.12. In the year 2000, what is the difference between the Exports(as % of merchandise exports) of Belarus and Exports(as % of merchandise exports) of Guyana?
Your answer should be very brief. -20.08. In the year 2000, what is the difference between the Exports(as % of merchandise exports) in Belarus and Exports(as % of merchandise exports) in Italy?
Offer a terse response. -0.63. In the year 2000, what is the difference between the Exports(as % of merchandise exports) of Guatemala and Exports(as % of merchandise exports) of Guyana?
Ensure brevity in your answer.  -18.96. In the year 2000, what is the difference between the Exports(as % of merchandise exports) of Guatemala and Exports(as % of merchandise exports) of Italy?
Give a very brief answer. 0.49. In the year 2000, what is the difference between the Exports(as % of merchandise exports) in Guyana and Exports(as % of merchandise exports) in Italy?
Offer a terse response. 19.45. In the year 2001, what is the difference between the Exports(as % of merchandise exports) in Belarus and Exports(as % of merchandise exports) in Guatemala?
Provide a short and direct response. -0.07. In the year 2001, what is the difference between the Exports(as % of merchandise exports) in Belarus and Exports(as % of merchandise exports) in Guyana?
Give a very brief answer. -21.01. In the year 2001, what is the difference between the Exports(as % of merchandise exports) of Belarus and Exports(as % of merchandise exports) of Italy?
Ensure brevity in your answer.  -0.44. In the year 2001, what is the difference between the Exports(as % of merchandise exports) in Guatemala and Exports(as % of merchandise exports) in Guyana?
Provide a succinct answer. -20.94. In the year 2001, what is the difference between the Exports(as % of merchandise exports) in Guatemala and Exports(as % of merchandise exports) in Italy?
Offer a very short reply. -0.37. In the year 2001, what is the difference between the Exports(as % of merchandise exports) in Guyana and Exports(as % of merchandise exports) in Italy?
Keep it short and to the point. 20.57. In the year 2002, what is the difference between the Exports(as % of merchandise exports) of Belarus and Exports(as % of merchandise exports) of Guatemala?
Ensure brevity in your answer.  0.71. In the year 2002, what is the difference between the Exports(as % of merchandise exports) of Belarus and Exports(as % of merchandise exports) of Guyana?
Keep it short and to the point. -7.89. In the year 2002, what is the difference between the Exports(as % of merchandise exports) of Belarus and Exports(as % of merchandise exports) of Italy?
Provide a succinct answer. 0.03. In the year 2002, what is the difference between the Exports(as % of merchandise exports) in Guatemala and Exports(as % of merchandise exports) in Guyana?
Your answer should be compact. -8.6. In the year 2002, what is the difference between the Exports(as % of merchandise exports) of Guatemala and Exports(as % of merchandise exports) of Italy?
Your answer should be compact. -0.68. In the year 2002, what is the difference between the Exports(as % of merchandise exports) of Guyana and Exports(as % of merchandise exports) of Italy?
Provide a short and direct response. 7.92. In the year 2003, what is the difference between the Exports(as % of merchandise exports) of Belarus and Exports(as % of merchandise exports) of Guatemala?
Your answer should be compact. 0.6. In the year 2003, what is the difference between the Exports(as % of merchandise exports) of Belarus and Exports(as % of merchandise exports) of Guyana?
Offer a terse response. -5.75. In the year 2003, what is the difference between the Exports(as % of merchandise exports) of Belarus and Exports(as % of merchandise exports) of Italy?
Offer a very short reply. -0.29. In the year 2003, what is the difference between the Exports(as % of merchandise exports) in Guatemala and Exports(as % of merchandise exports) in Guyana?
Provide a succinct answer. -6.35. In the year 2003, what is the difference between the Exports(as % of merchandise exports) of Guatemala and Exports(as % of merchandise exports) of Italy?
Your response must be concise. -0.89. In the year 2003, what is the difference between the Exports(as % of merchandise exports) of Guyana and Exports(as % of merchandise exports) of Italy?
Keep it short and to the point. 5.46. In the year 2004, what is the difference between the Exports(as % of merchandise exports) in Belarus and Exports(as % of merchandise exports) in Guatemala?
Offer a very short reply. 0.24. In the year 2004, what is the difference between the Exports(as % of merchandise exports) of Belarus and Exports(as % of merchandise exports) of Guyana?
Offer a terse response. -5.67. In the year 2004, what is the difference between the Exports(as % of merchandise exports) of Belarus and Exports(as % of merchandise exports) of Italy?
Make the answer very short. -0.69. In the year 2004, what is the difference between the Exports(as % of merchandise exports) in Guatemala and Exports(as % of merchandise exports) in Guyana?
Offer a very short reply. -5.9. In the year 2004, what is the difference between the Exports(as % of merchandise exports) of Guatemala and Exports(as % of merchandise exports) of Italy?
Provide a succinct answer. -0.92. In the year 2004, what is the difference between the Exports(as % of merchandise exports) of Guyana and Exports(as % of merchandise exports) of Italy?
Provide a succinct answer. 4.98. In the year 2005, what is the difference between the Exports(as % of merchandise exports) of Belarus and Exports(as % of merchandise exports) of Guatemala?
Offer a very short reply. 0.03. In the year 2005, what is the difference between the Exports(as % of merchandise exports) in Belarus and Exports(as % of merchandise exports) in Guyana?
Your response must be concise. -7.82. In the year 2005, what is the difference between the Exports(as % of merchandise exports) in Belarus and Exports(as % of merchandise exports) in Italy?
Your response must be concise. -0.94. In the year 2005, what is the difference between the Exports(as % of merchandise exports) of Guatemala and Exports(as % of merchandise exports) of Guyana?
Provide a short and direct response. -7.85. In the year 2005, what is the difference between the Exports(as % of merchandise exports) of Guatemala and Exports(as % of merchandise exports) of Italy?
Your answer should be compact. -0.97. In the year 2005, what is the difference between the Exports(as % of merchandise exports) of Guyana and Exports(as % of merchandise exports) of Italy?
Ensure brevity in your answer.  6.87. What is the ratio of the Exports(as % of merchandise exports) in Belarus in 1999 to that in 2000?
Your answer should be very brief. 0.99. What is the ratio of the Exports(as % of merchandise exports) of Guatemala in 1999 to that in 2000?
Provide a succinct answer. 0.37. What is the ratio of the Exports(as % of merchandise exports) of Guyana in 1999 to that in 2000?
Make the answer very short. 0.7. What is the ratio of the Exports(as % of merchandise exports) in Italy in 1999 to that in 2000?
Offer a very short reply. 0.92. What is the ratio of the Exports(as % of merchandise exports) in Belarus in 1999 to that in 2001?
Make the answer very short. 0.84. What is the ratio of the Exports(as % of merchandise exports) in Guatemala in 1999 to that in 2001?
Keep it short and to the point. 0.73. What is the ratio of the Exports(as % of merchandise exports) of Guyana in 1999 to that in 2001?
Your response must be concise. 0.67. What is the ratio of the Exports(as % of merchandise exports) of Italy in 1999 to that in 2001?
Your response must be concise. 0.96. What is the ratio of the Exports(as % of merchandise exports) of Belarus in 1999 to that in 2002?
Offer a terse response. 0.56. What is the ratio of the Exports(as % of merchandise exports) in Guatemala in 1999 to that in 2002?
Provide a succinct answer. 1.11. What is the ratio of the Exports(as % of merchandise exports) of Guyana in 1999 to that in 2002?
Make the answer very short. 1.59. What is the ratio of the Exports(as % of merchandise exports) in Italy in 1999 to that in 2002?
Give a very brief answer. 0.98. What is the ratio of the Exports(as % of merchandise exports) of Belarus in 1999 to that in 2003?
Provide a succinct answer. 0.76. What is the ratio of the Exports(as % of merchandise exports) in Guatemala in 1999 to that in 2003?
Your response must be concise. 1.82. What is the ratio of the Exports(as % of merchandise exports) of Guyana in 1999 to that in 2003?
Your answer should be compact. 2.18. What is the ratio of the Exports(as % of merchandise exports) of Belarus in 1999 to that in 2004?
Provide a succinct answer. 1.02. What is the ratio of the Exports(as % of merchandise exports) of Guatemala in 1999 to that in 2004?
Keep it short and to the point. 1.4. What is the ratio of the Exports(as % of merchandise exports) in Guyana in 1999 to that in 2004?
Make the answer very short. 2.29. What is the ratio of the Exports(as % of merchandise exports) of Italy in 1999 to that in 2004?
Make the answer very short. 0.9. What is the ratio of the Exports(as % of merchandise exports) of Belarus in 1999 to that in 2005?
Your response must be concise. 1.41. What is the ratio of the Exports(as % of merchandise exports) in Guatemala in 1999 to that in 2005?
Your answer should be compact. 1.39. What is the ratio of the Exports(as % of merchandise exports) of Guyana in 1999 to that in 2005?
Your answer should be compact. 1.75. What is the ratio of the Exports(as % of merchandise exports) in Italy in 1999 to that in 2005?
Offer a very short reply. 0.86. What is the ratio of the Exports(as % of merchandise exports) in Belarus in 2000 to that in 2001?
Offer a very short reply. 0.85. What is the ratio of the Exports(as % of merchandise exports) of Guatemala in 2000 to that in 2001?
Your response must be concise. 1.96. What is the ratio of the Exports(as % of merchandise exports) in Guyana in 2000 to that in 2001?
Ensure brevity in your answer.  0.95. What is the ratio of the Exports(as % of merchandise exports) of Italy in 2000 to that in 2001?
Offer a very short reply. 1.04. What is the ratio of the Exports(as % of merchandise exports) in Belarus in 2000 to that in 2002?
Offer a very short reply. 0.56. What is the ratio of the Exports(as % of merchandise exports) of Guatemala in 2000 to that in 2002?
Give a very brief answer. 2.98. What is the ratio of the Exports(as % of merchandise exports) of Guyana in 2000 to that in 2002?
Provide a short and direct response. 2.26. What is the ratio of the Exports(as % of merchandise exports) in Italy in 2000 to that in 2002?
Provide a succinct answer. 1.06. What is the ratio of the Exports(as % of merchandise exports) of Belarus in 2000 to that in 2003?
Your answer should be very brief. 0.77. What is the ratio of the Exports(as % of merchandise exports) of Guatemala in 2000 to that in 2003?
Offer a terse response. 4.86. What is the ratio of the Exports(as % of merchandise exports) in Guyana in 2000 to that in 2003?
Your answer should be compact. 3.09. What is the ratio of the Exports(as % of merchandise exports) in Italy in 2000 to that in 2003?
Offer a very short reply. 1.08. What is the ratio of the Exports(as % of merchandise exports) of Belarus in 2000 to that in 2004?
Give a very brief answer. 1.02. What is the ratio of the Exports(as % of merchandise exports) in Guatemala in 2000 to that in 2004?
Your answer should be very brief. 3.75. What is the ratio of the Exports(as % of merchandise exports) of Guyana in 2000 to that in 2004?
Offer a terse response. 3.25. What is the ratio of the Exports(as % of merchandise exports) of Italy in 2000 to that in 2004?
Your response must be concise. 0.97. What is the ratio of the Exports(as % of merchandise exports) in Belarus in 2000 to that in 2005?
Provide a succinct answer. 1.42. What is the ratio of the Exports(as % of merchandise exports) in Guatemala in 2000 to that in 2005?
Offer a terse response. 3.72. What is the ratio of the Exports(as % of merchandise exports) of Guyana in 2000 to that in 2005?
Provide a short and direct response. 2.5. What is the ratio of the Exports(as % of merchandise exports) of Italy in 2000 to that in 2005?
Ensure brevity in your answer.  0.94. What is the ratio of the Exports(as % of merchandise exports) in Belarus in 2001 to that in 2002?
Provide a short and direct response. 0.67. What is the ratio of the Exports(as % of merchandise exports) of Guatemala in 2001 to that in 2002?
Your answer should be compact. 1.52. What is the ratio of the Exports(as % of merchandise exports) of Guyana in 2001 to that in 2002?
Offer a very short reply. 2.37. What is the ratio of the Exports(as % of merchandise exports) of Italy in 2001 to that in 2002?
Provide a short and direct response. 1.02. What is the ratio of the Exports(as % of merchandise exports) in Belarus in 2001 to that in 2003?
Offer a very short reply. 0.9. What is the ratio of the Exports(as % of merchandise exports) in Guatemala in 2001 to that in 2003?
Provide a succinct answer. 2.48. What is the ratio of the Exports(as % of merchandise exports) in Guyana in 2001 to that in 2003?
Provide a short and direct response. 3.25. What is the ratio of the Exports(as % of merchandise exports) in Italy in 2001 to that in 2003?
Provide a succinct answer. 1.04. What is the ratio of the Exports(as % of merchandise exports) in Belarus in 2001 to that in 2004?
Make the answer very short. 1.21. What is the ratio of the Exports(as % of merchandise exports) of Guatemala in 2001 to that in 2004?
Give a very brief answer. 1.92. What is the ratio of the Exports(as % of merchandise exports) in Guyana in 2001 to that in 2004?
Keep it short and to the point. 3.42. What is the ratio of the Exports(as % of merchandise exports) in Italy in 2001 to that in 2004?
Provide a short and direct response. 0.93. What is the ratio of the Exports(as % of merchandise exports) of Belarus in 2001 to that in 2005?
Your response must be concise. 1.67. What is the ratio of the Exports(as % of merchandise exports) in Guatemala in 2001 to that in 2005?
Your answer should be compact. 1.9. What is the ratio of the Exports(as % of merchandise exports) in Guyana in 2001 to that in 2005?
Offer a terse response. 2.62. What is the ratio of the Exports(as % of merchandise exports) in Italy in 2001 to that in 2005?
Provide a succinct answer. 0.9. What is the ratio of the Exports(as % of merchandise exports) of Belarus in 2002 to that in 2003?
Offer a terse response. 1.36. What is the ratio of the Exports(as % of merchandise exports) of Guatemala in 2002 to that in 2003?
Offer a terse response. 1.63. What is the ratio of the Exports(as % of merchandise exports) in Guyana in 2002 to that in 2003?
Offer a very short reply. 1.37. What is the ratio of the Exports(as % of merchandise exports) in Italy in 2002 to that in 2003?
Keep it short and to the point. 1.02. What is the ratio of the Exports(as % of merchandise exports) in Belarus in 2002 to that in 2004?
Offer a terse response. 1.81. What is the ratio of the Exports(as % of merchandise exports) in Guatemala in 2002 to that in 2004?
Your answer should be very brief. 1.26. What is the ratio of the Exports(as % of merchandise exports) in Guyana in 2002 to that in 2004?
Keep it short and to the point. 1.44. What is the ratio of the Exports(as % of merchandise exports) of Italy in 2002 to that in 2004?
Provide a short and direct response. 0.92. What is the ratio of the Exports(as % of merchandise exports) in Belarus in 2002 to that in 2005?
Offer a terse response. 2.51. What is the ratio of the Exports(as % of merchandise exports) of Guatemala in 2002 to that in 2005?
Your answer should be compact. 1.25. What is the ratio of the Exports(as % of merchandise exports) of Guyana in 2002 to that in 2005?
Offer a terse response. 1.1. What is the ratio of the Exports(as % of merchandise exports) of Italy in 2002 to that in 2005?
Make the answer very short. 0.88. What is the ratio of the Exports(as % of merchandise exports) of Belarus in 2003 to that in 2004?
Your response must be concise. 1.34. What is the ratio of the Exports(as % of merchandise exports) of Guatemala in 2003 to that in 2004?
Keep it short and to the point. 0.77. What is the ratio of the Exports(as % of merchandise exports) in Guyana in 2003 to that in 2004?
Give a very brief answer. 1.05. What is the ratio of the Exports(as % of merchandise exports) in Italy in 2003 to that in 2004?
Your answer should be compact. 0.9. What is the ratio of the Exports(as % of merchandise exports) of Belarus in 2003 to that in 2005?
Give a very brief answer. 1.85. What is the ratio of the Exports(as % of merchandise exports) in Guatemala in 2003 to that in 2005?
Provide a short and direct response. 0.76. What is the ratio of the Exports(as % of merchandise exports) in Guyana in 2003 to that in 2005?
Give a very brief answer. 0.81. What is the ratio of the Exports(as % of merchandise exports) of Italy in 2003 to that in 2005?
Your response must be concise. 0.86. What is the ratio of the Exports(as % of merchandise exports) in Belarus in 2004 to that in 2005?
Keep it short and to the point. 1.38. What is the ratio of the Exports(as % of merchandise exports) in Guatemala in 2004 to that in 2005?
Offer a terse response. 0.99. What is the ratio of the Exports(as % of merchandise exports) of Guyana in 2004 to that in 2005?
Offer a terse response. 0.77. What is the ratio of the Exports(as % of merchandise exports) of Italy in 2004 to that in 2005?
Provide a succinct answer. 0.96. What is the difference between the highest and the second highest Exports(as % of merchandise exports) of Belarus?
Your answer should be very brief. 0.35. What is the difference between the highest and the second highest Exports(as % of merchandise exports) in Guatemala?
Keep it short and to the point. 0.92. What is the difference between the highest and the second highest Exports(as % of merchandise exports) of Guyana?
Make the answer very short. 1.06. What is the difference between the highest and the second highest Exports(as % of merchandise exports) in Italy?
Offer a very short reply. 0.05. What is the difference between the highest and the lowest Exports(as % of merchandise exports) in Belarus?
Your response must be concise. 0.8. What is the difference between the highest and the lowest Exports(as % of merchandise exports) in Guatemala?
Provide a short and direct response. 1.49. What is the difference between the highest and the lowest Exports(as % of merchandise exports) in Guyana?
Provide a short and direct response. 15.5. What is the difference between the highest and the lowest Exports(as % of merchandise exports) of Italy?
Make the answer very short. 0.2. 